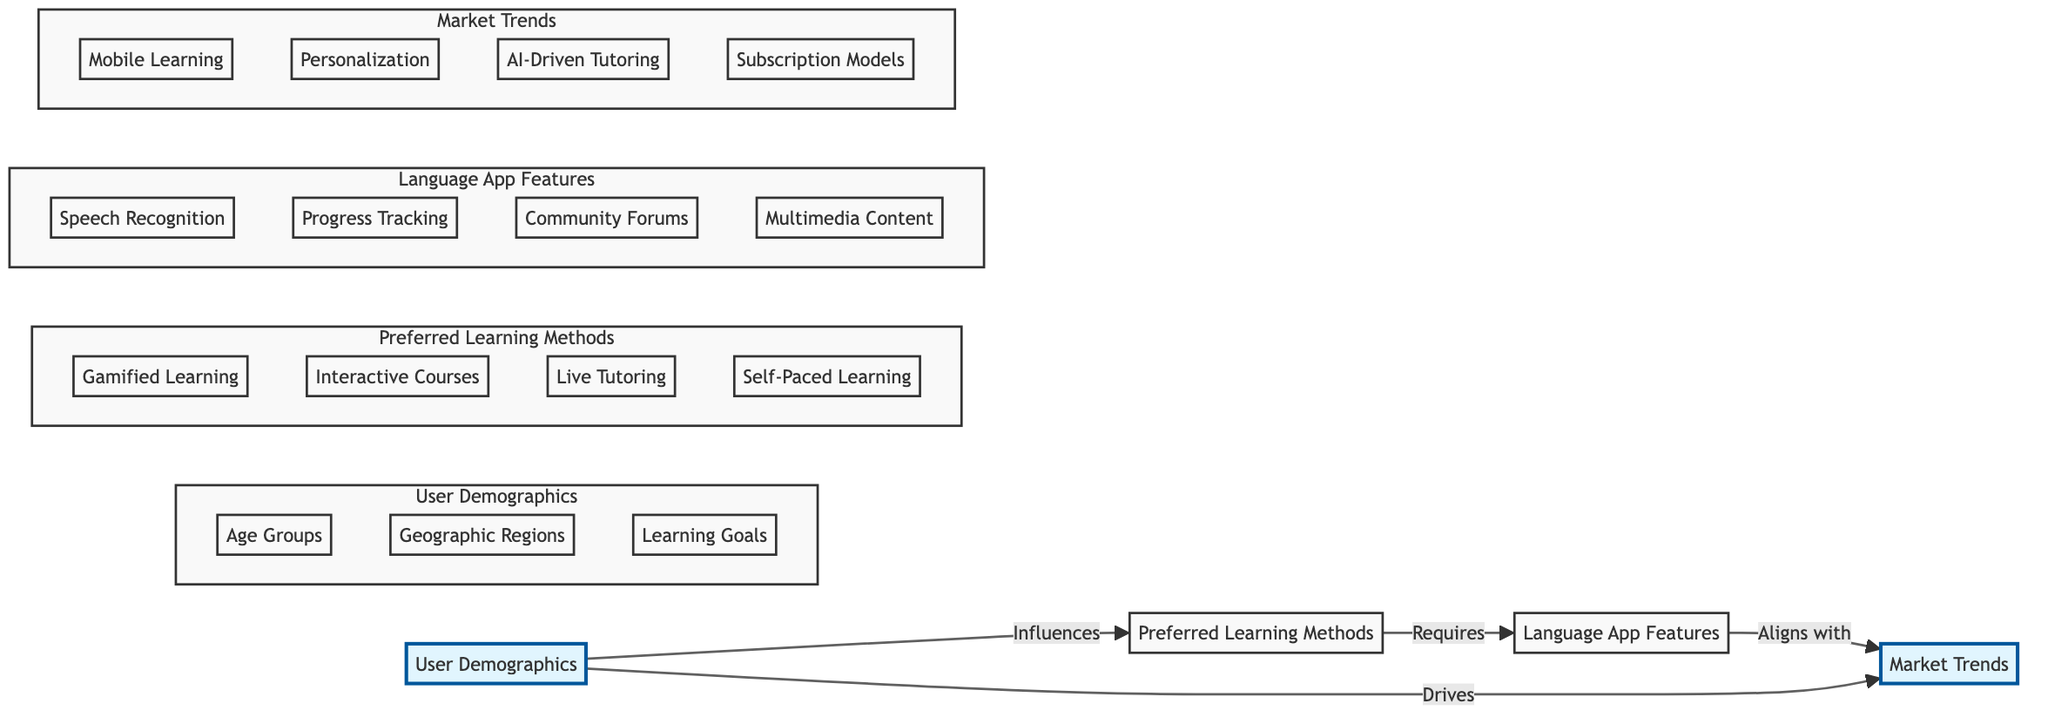What influences preferred learning methods? The diagram shows that "User Demographics" influences "Preferred Learning Methods." This is represented by the directed edge labeled "Influences" connecting the two nodes.
Answer: User Demographics How many preferred learning methods are shown in the diagram? There are four preferred learning methods listed under the "Preferred Learning Methods" node: Gamified Learning, Interactive Courses, Live Tutoring, and Self-Paced Learning.
Answer: Four Which node aligns with market trends? According to the diagram, "Language App Features" aligns with "Market Trends," as indicated by the directed edge labeled "Aligns with."
Answer: Language App Features What drives market trends according to the diagram? The diagram indicates that "User Demographics" drives "Market Trends," as shown by the directed edge labeled "Drives."
Answer: User Demographics Which preferred learning method requires language app features? The directed edge labeled "Requires" from "Preferred Learning Methods" to "Language App Features" allows us to understand that all preferred learning methods collectively require various features, but if the question asks for a specific method, we can state that all do.
Answer: All preferred learning methods How many edges are present in the diagram? The diagram shows four edges connecting the nodes, which represent the relationships between the user demographics, preferred learning methods, language app features, and market trends.
Answer: Four What age group is part of user demographics? "Age Groups," which includes segments such as 18-24, 25-34, 35-44, and 45+, is a subdivision of "User Demographics."
Answer: 18-24, 25-34, 35-44, 45+ Which features are necessary for preferred learning methods? "Language App Features" is indicated to be necessary for preferred learning methods, which include Speech Recognition, Progress Tracking, Community Forums, and Multimedia Content as per the features that can enhance learning experiences.
Answer: Speech Recognition, Progress Tracking, Community Forums, Multimedia Content What market trend is related to user demographics? The diagram shows that "Market Trends" is driven by "User Demographics," meaning the shifts in demographics are factors influencing overall market trends.
Answer: Market Trends 